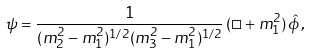Convert formula to latex. <formula><loc_0><loc_0><loc_500><loc_500>\psi = \frac { 1 } { ( m _ { 2 } ^ { 2 } - m _ { 1 } ^ { 2 } ) ^ { 1 / 2 } ( m _ { 3 } ^ { 2 } - m _ { 1 } ^ { 2 } ) ^ { 1 / 2 } } \, ( \Box + m _ { 1 } ^ { 2 } ) \, \hat { \phi } \, ,</formula> 